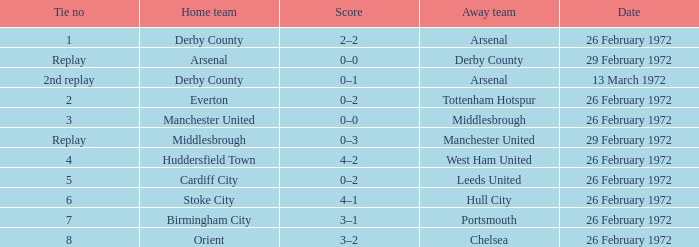Which necktie is from everton? 2.0. 